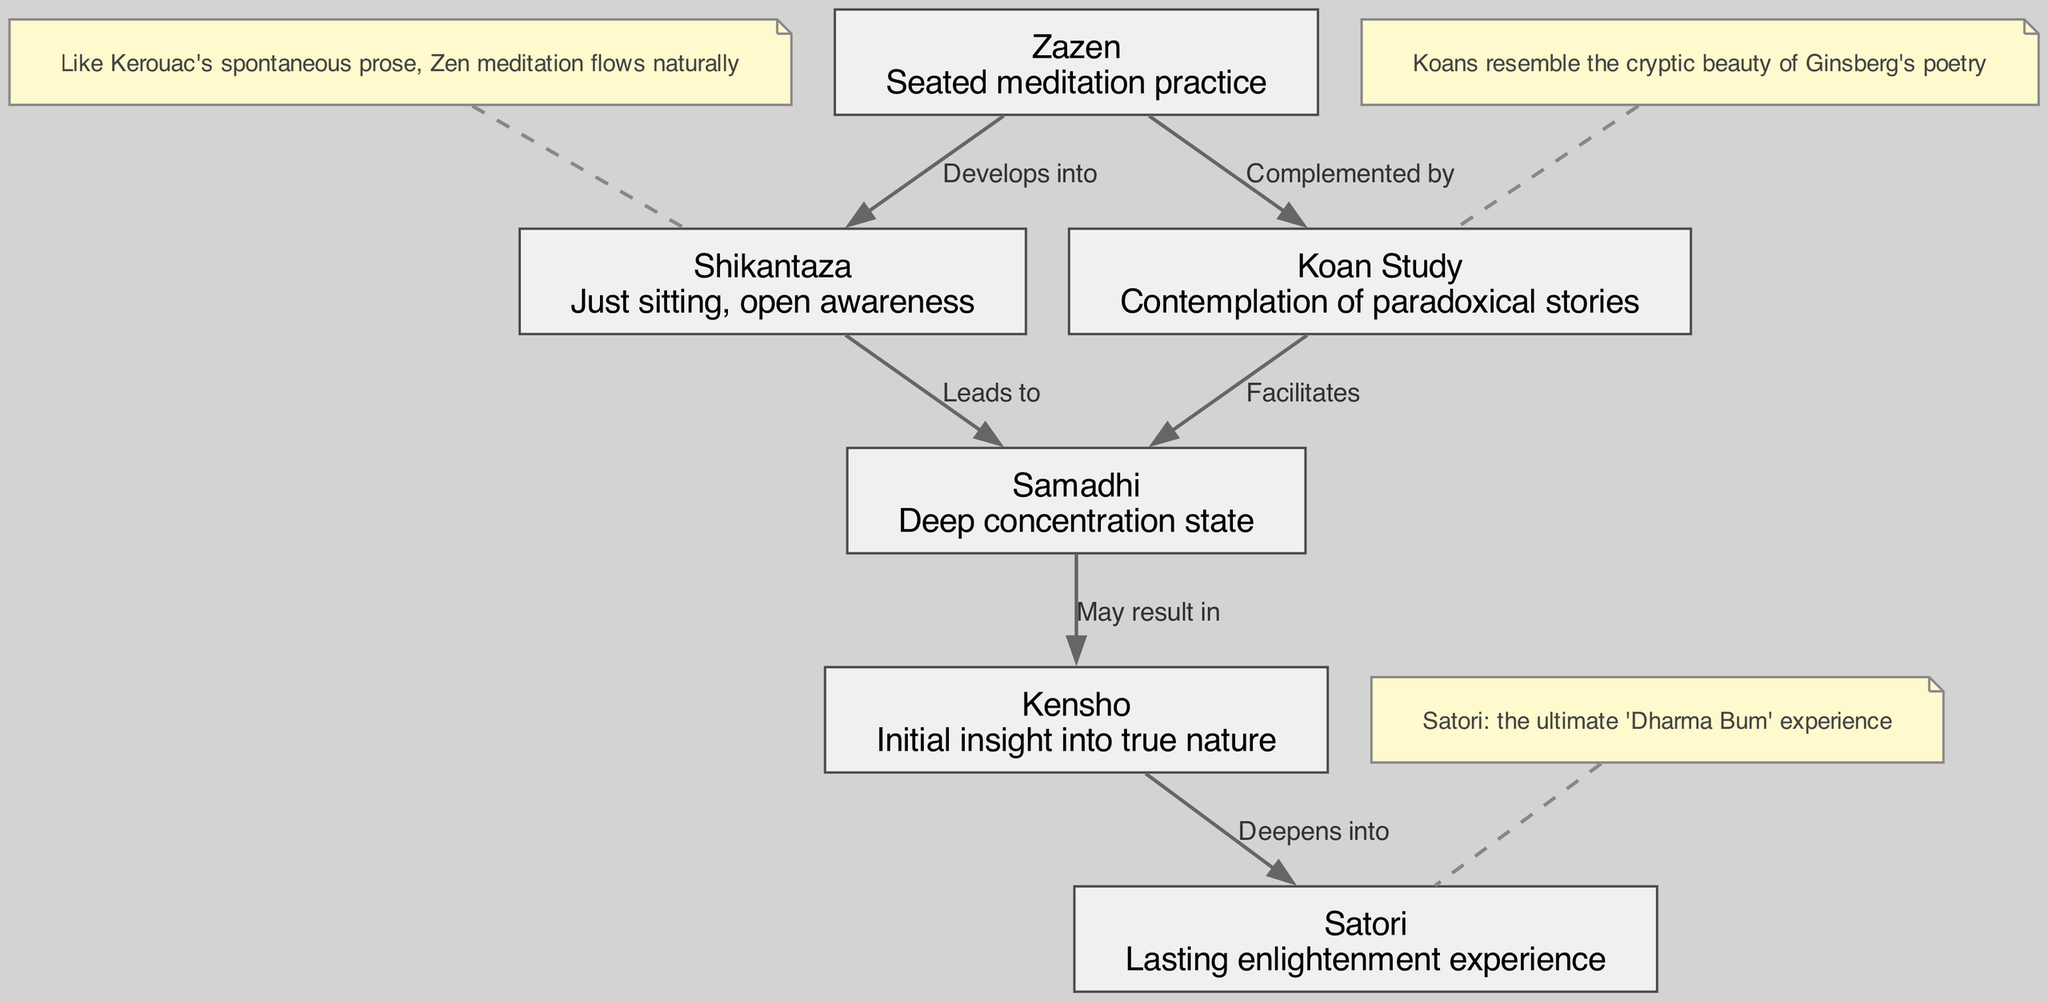What is the first stage of Zen meditation? The first node in the diagram represents the initial stage of Zen meditation, labeled "Zazen." This node describes it as a "Seated meditation practice."
Answer: Zazen How many stages are depicted in the diagram? By counting the nodes listed in the diagram, there are a total of six stages of Zen meditation indicated.
Answer: Six Which stage develops into Shikantaza? The diagram shows an edge directed from "Zazen" to "Shikantaza" labeled "Develops into," indicating this relationship clearly.
Answer: Zazen What effect does Koan Study facilitate? The diagram shows an edge from "Koan Study" to "Samadhi" with the label "Facilitates," indicating this effect in the context of Zen meditation.
Answer: Samadhi What results from deep concentration state? The diagram clearly connects the node "Samadhi" to "Kensho" with an edge labeled "May result in," indicating the relationship between these two stages.
Answer: Kensho Which enlightenment experience deepens from Kensho? According to the diagram, there is an edge going from "Kensho" to "Satori," labeled "Deepens into," which specifies the flow of enlightenment experiences.
Answer: Satori What does the annotation associated with Shikantaza express? The annotation linked to "Shikantaza" notes, "Like Kerouac's spontaneous prose, Zen meditation flows naturally," illustrating a poetic connection.
Answer: Like Kerouac's spontaneous prose, Zen meditation flows naturally How does Koan Study relate to Samadhi and Zazen? The diagram shows that "Koan Study" complements "Zazen" and facilitates "Samadhi." This indicates it enhances both initial and deeper states of meditation.
Answer: Complements Zazen and facilitates Samadhi 